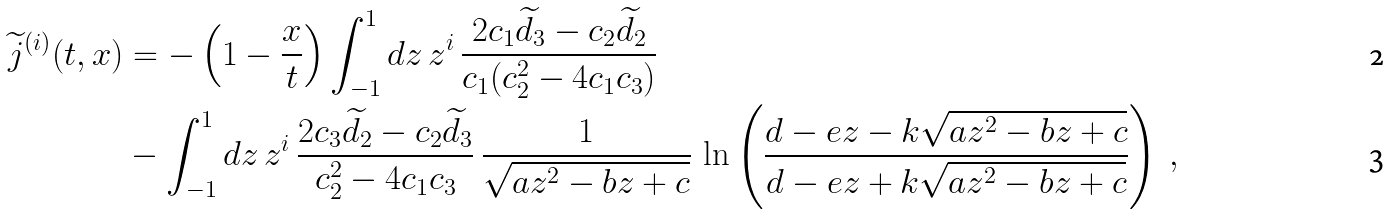<formula> <loc_0><loc_0><loc_500><loc_500>\widetilde { j } ^ { ( i ) } ( t , x ) & = - \left ( 1 - \frac { x } { t } \right ) \int _ { - 1 } ^ { 1 } d z \, z ^ { i } \, \frac { 2 c _ { 1 } \widetilde { d } _ { 3 } - c _ { 2 } \widetilde { d } _ { 2 } } { c _ { 1 } ( c _ { 2 } ^ { 2 } - 4 c _ { 1 } c _ { 3 } ) } \\ & - \int _ { - 1 } ^ { 1 } d z \, z ^ { i } \, \frac { 2 c _ { 3 } \widetilde { d } _ { 2 } - c _ { 2 } \widetilde { d } _ { 3 } } { c _ { 2 } ^ { 2 } - 4 c _ { 1 } c _ { 3 } } \, \frac { 1 } { \sqrt { a z ^ { 2 } - b z + c } } \, \ln \left ( \frac { d - e z - k \sqrt { a z ^ { 2 } - b z + c } } { d - e z + k \sqrt { a z ^ { 2 } - b z + c } } \right ) \, ,</formula> 